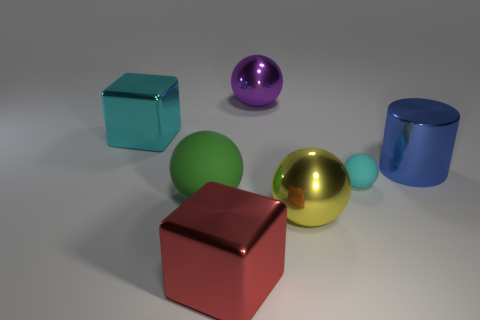Can you describe the shapes and colors that you see in the image? Certainly, the image displays a collection of geometric shapes including a large cyan cube, a smaller green sphere, a gold sphere, a purple sphere, a red cube, and a blue cylinder. They are arranged on a plain surface with a subtle shadow beneath each object, highlighting the three-dimensional rendering. 